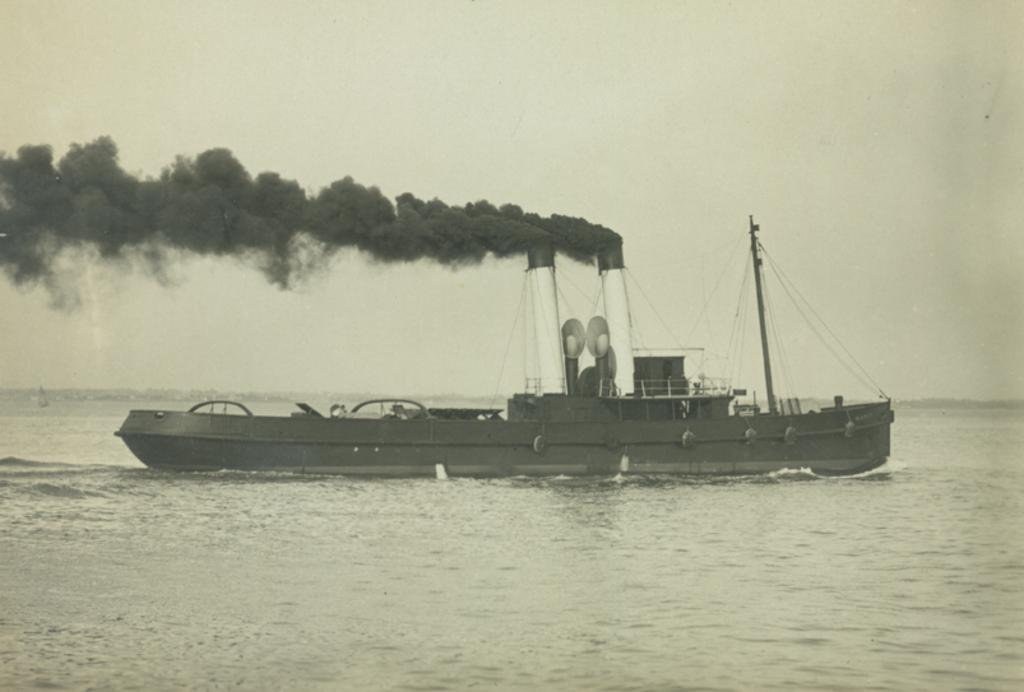What is the main subject of the image? The main subject of the image is a ship. What is the ship doing in the image? The ship is sailing in the water. What can be seen on the ship? There are containers, a pole, and ropes on the ship. What is happening with the ship in the image? There is smoke coming from the ship. What is visible in the background of the image? The sky is visible in the background of the image. Where is the playground apparatus located in the image? There is no playground apparatus present in the image; it features a ship sailing in the water. What type of grain can be seen being loaded onto the ship in the image? There is no grain visible in the image; it only shows a ship with containers, a pole, and ropes. 